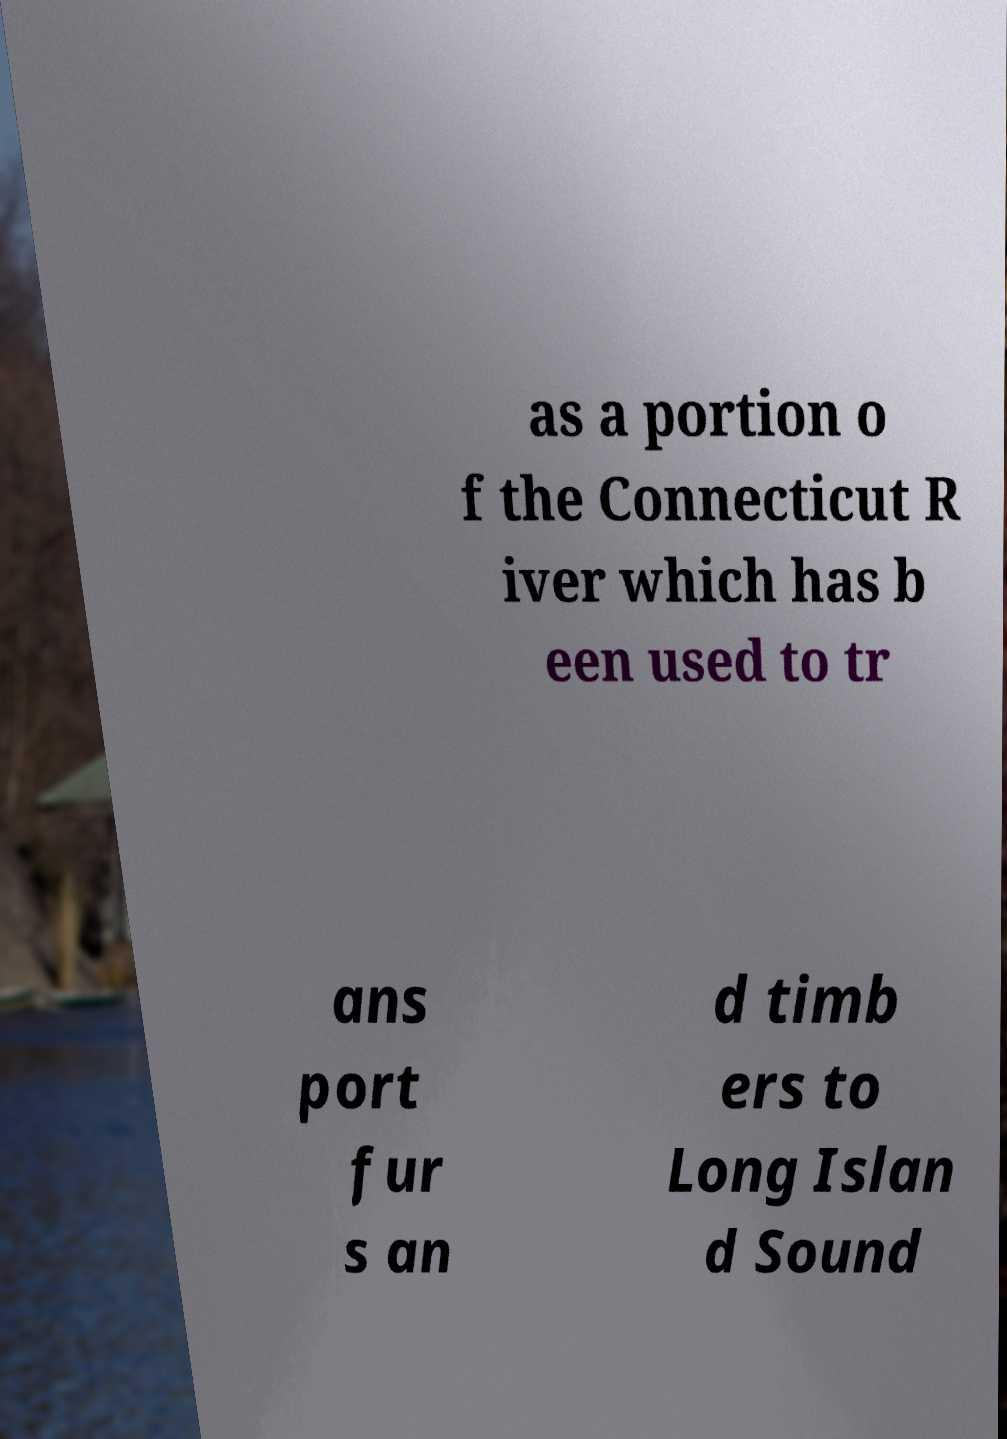What messages or text are displayed in this image? I need them in a readable, typed format. as a portion o f the Connecticut R iver which has b een used to tr ans port fur s an d timb ers to Long Islan d Sound 